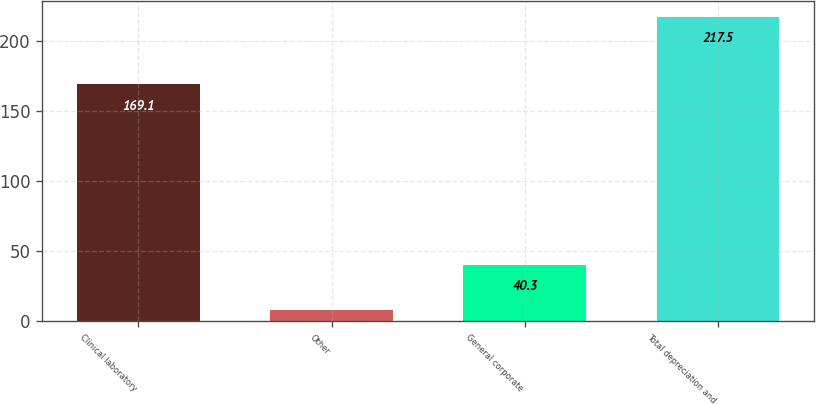<chart> <loc_0><loc_0><loc_500><loc_500><bar_chart><fcel>Clinical laboratory<fcel>Other<fcel>General corporate<fcel>Total depreciation and<nl><fcel>169.1<fcel>8.1<fcel>40.3<fcel>217.5<nl></chart> 